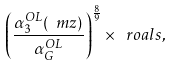Convert formula to latex. <formula><loc_0><loc_0><loc_500><loc_500>\left ( \frac { \alpha _ { 3 } ^ { O L } ( \ m z ) } { \alpha _ { G } ^ { O L } } \right ) ^ { \frac { 8 } { 9 } } \times \ r o a l s ,</formula> 